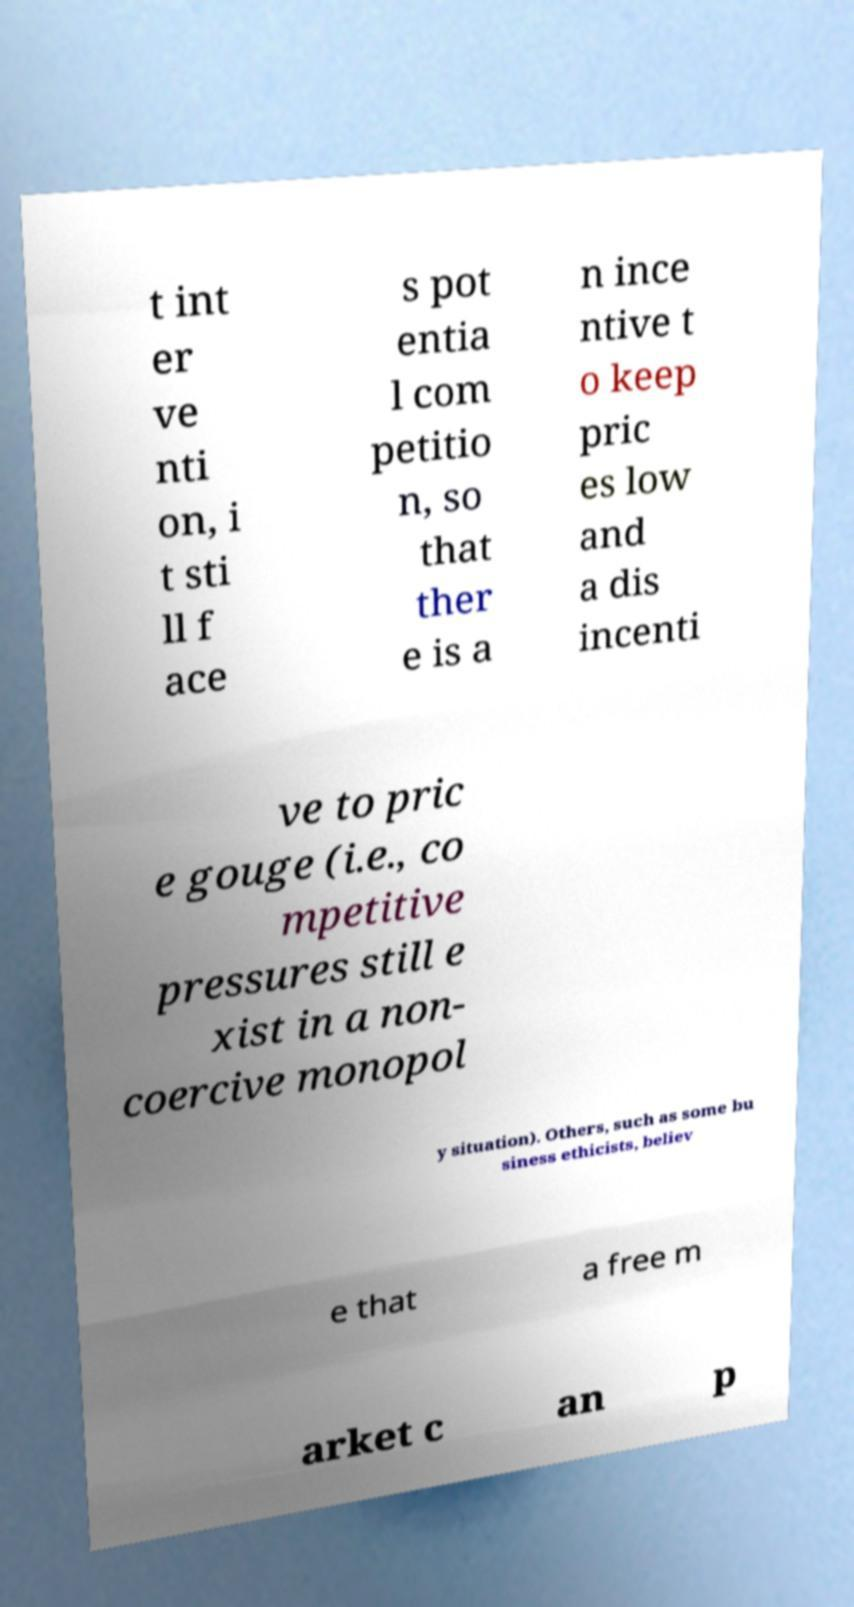I need the written content from this picture converted into text. Can you do that? t int er ve nti on, i t sti ll f ace s pot entia l com petitio n, so that ther e is a n ince ntive t o keep pric es low and a dis incenti ve to pric e gouge (i.e., co mpetitive pressures still e xist in a non- coercive monopol y situation). Others, such as some bu siness ethicists, believ e that a free m arket c an p 